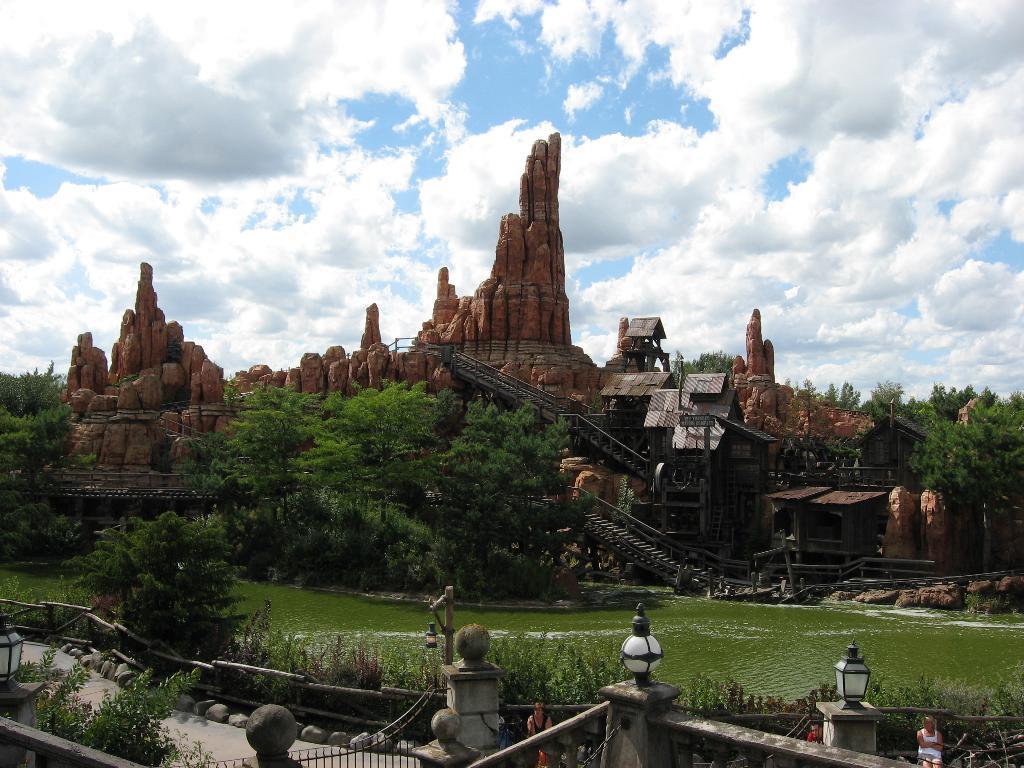How would you summarize this image in a sentence or two? In this image I can see the water and I can see few trees and plants in green color. Background I can see few rocks and I can see few hits. In the background the sky is in blue and white color. 